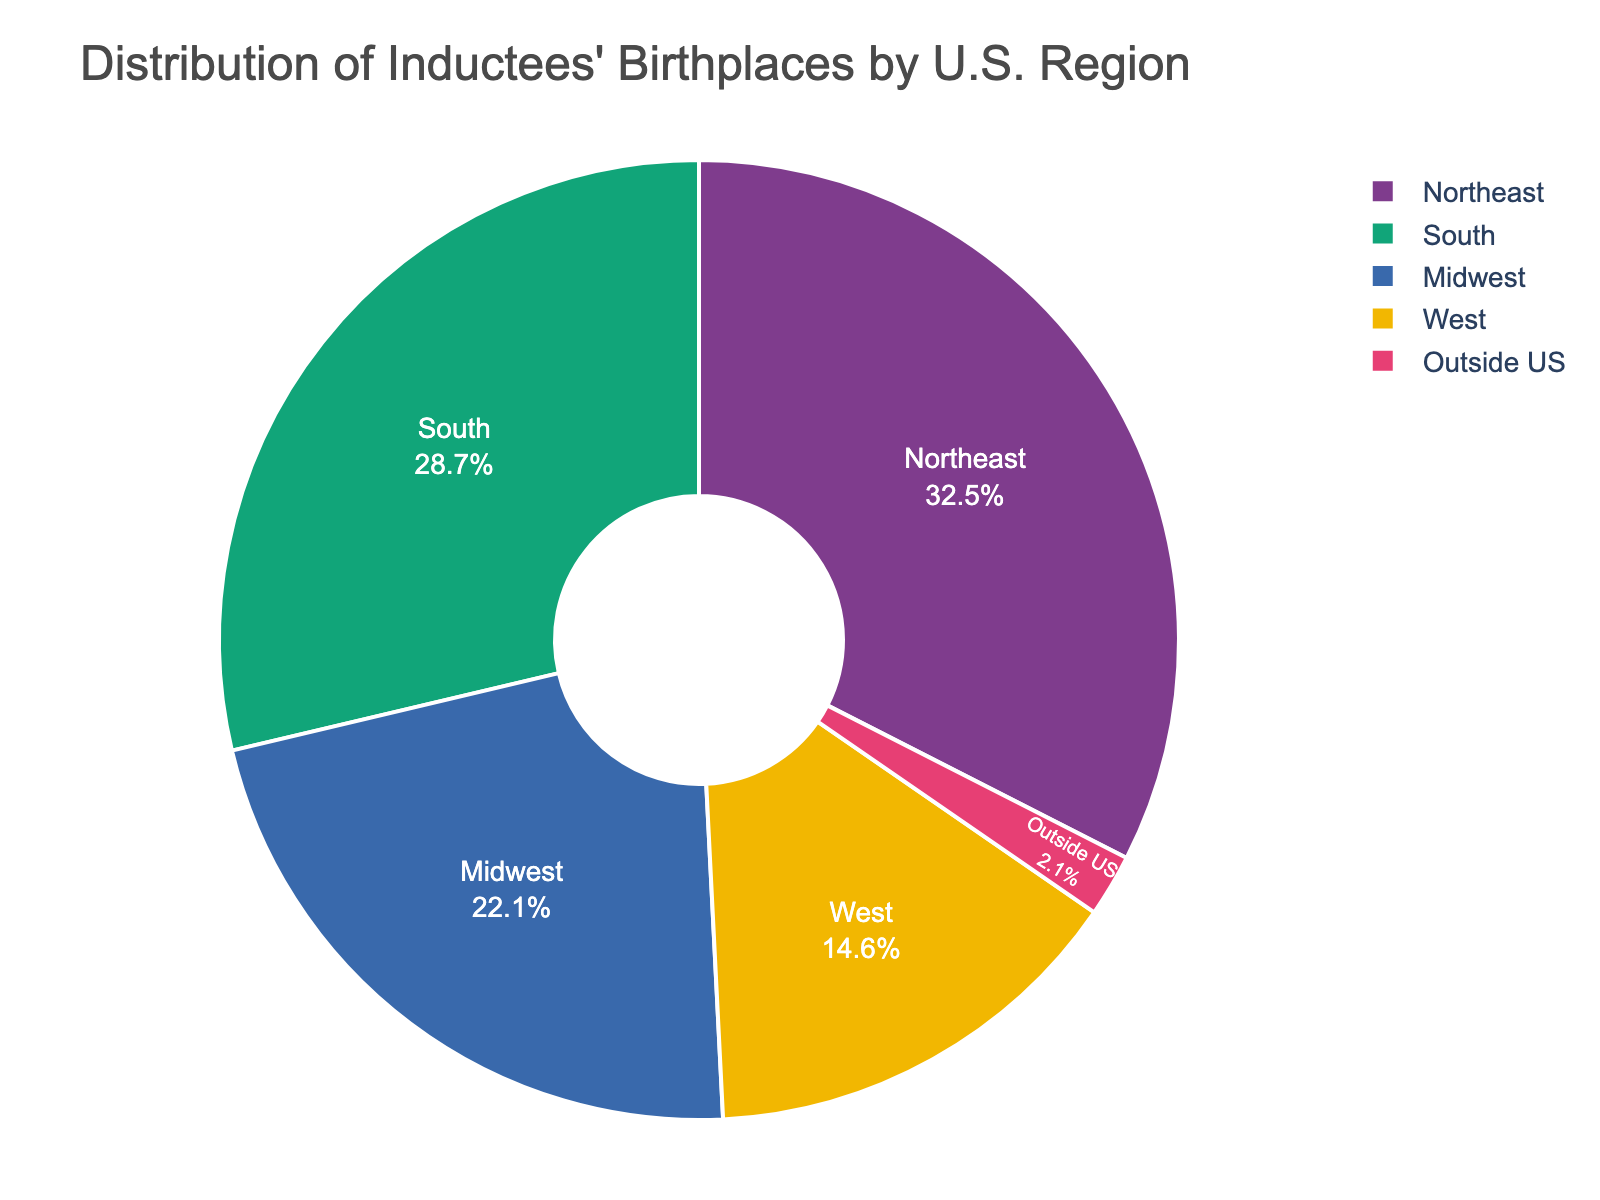Which region has the highest percentage of inductees' birthplaces? The chart shows the percentages of inductees' birthplaces for different regions. The Northeast is the largest segment with 32.5%. Therefore, the Northeast has the highest percentage.
Answer: Northeast What is the total percentage of inductees' birthplaces from the Midwest and West combined? To find the total percentage from the Midwest and West, add their individual percentages: 22.1% (Midwest) + 14.6% (West) = 36.7%.
Answer: 36.7% How much greater is the percentage of inductees' birthplaces in the Northeast compared to Outside US? To find the difference, subtract the percentage of Outside US from the Northeast: 32.5% (Northeast) - 2.1% (Outside US) = 30.4%.
Answer: 30.4% Which region has a smaller percentage of inductees' birthplaces, the South or the West? Compare the percentages: South has 28.7% and West has 14.6%. The West has a smaller percentage.
Answer: West If you combine the percentages from the Northeast and the South, do their inductees' birthplaces make up more than half of the total? Combine the percentages: 32.5% (Northeast) + 28.7% (South) = 61.2%. Since 61.2% is greater than 50%, they make up more than half of the total.
Answer: Yes What is the visual representation of the Midwest region, and how does it compare to the West region? The Midwest region is presented as a segment that is smaller than the segments of both the Northeast and the South but larger than the West. By comparing the visual area, the Midwest's segment is visually larger than the West's segment.
Answer: Larger Calculate the average percentage of inductees' birthplaces from all specified U.S regions (excluding Outside US). Add the percentages from the Northeast, South, Midwest, and West and divide by the number of these regions: (32.5% + 28.7% + 22.1% + 14.6%) / 4 = 24.475%.
Answer: 24.475% What is the approximate difference between the percentages of inductees' birthplaces in the South and the Midwest? Subtract the Midwest percentage from the South percentage: 28.7% (South) - 22.1% (Midwest) = 6.6%.
Answer: 6.6% 